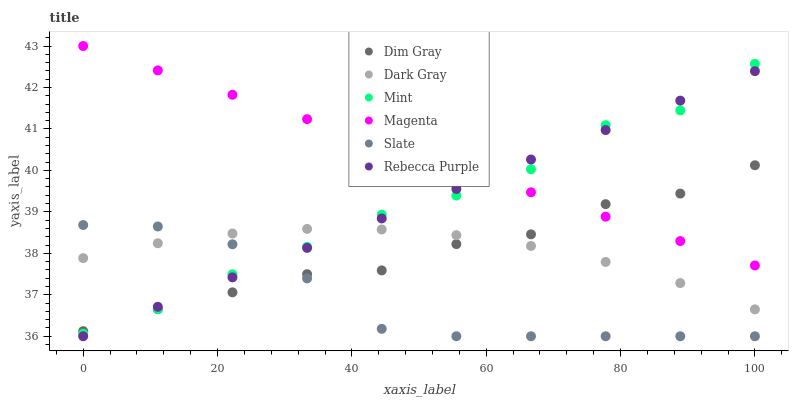Does Slate have the minimum area under the curve?
Answer yes or no. Yes. Does Magenta have the maximum area under the curve?
Answer yes or no. Yes. Does Dark Gray have the minimum area under the curve?
Answer yes or no. No. Does Dark Gray have the maximum area under the curve?
Answer yes or no. No. Is Magenta the smoothest?
Answer yes or no. Yes. Is Mint the roughest?
Answer yes or no. Yes. Is Slate the smoothest?
Answer yes or no. No. Is Slate the roughest?
Answer yes or no. No. Does Slate have the lowest value?
Answer yes or no. Yes. Does Dark Gray have the lowest value?
Answer yes or no. No. Does Magenta have the highest value?
Answer yes or no. Yes. Does Slate have the highest value?
Answer yes or no. No. Is Dark Gray less than Magenta?
Answer yes or no. Yes. Is Magenta greater than Dark Gray?
Answer yes or no. Yes. Does Magenta intersect Rebecca Purple?
Answer yes or no. Yes. Is Magenta less than Rebecca Purple?
Answer yes or no. No. Is Magenta greater than Rebecca Purple?
Answer yes or no. No. Does Dark Gray intersect Magenta?
Answer yes or no. No. 